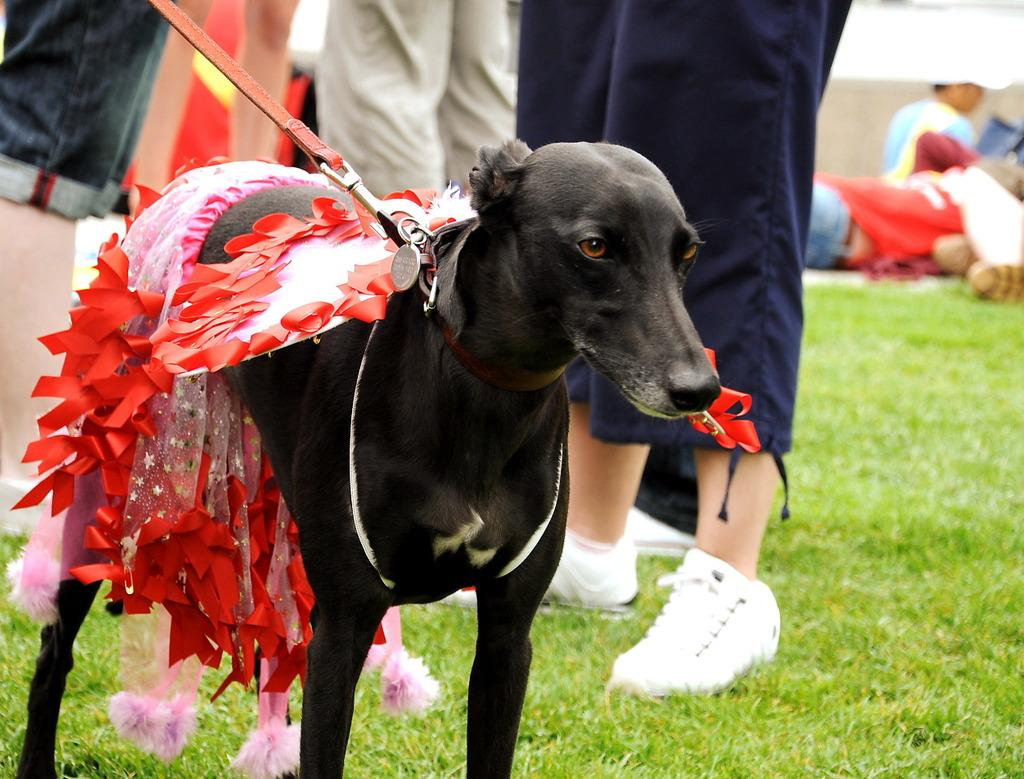What type of vegetation is at the bottom of the image? There is grass at the bottom of the image. What animal can be seen in the middle of the image? There is a black dog in the middle of the image. What is unique about the dog's appearance? The dog has a belt and a dress. Are there any other people or animals visible in the image? Yes, there are legs of other persons visible in the middle of the image. How many mice are hiding under the dog's dress in the image? There are no mice present in the image, and therefore no mice can be found under the dog's dress. What type of test is being conducted on the dog in the image? There is no test being conducted on the dog in the image; it is simply wearing a belt and a dress. 